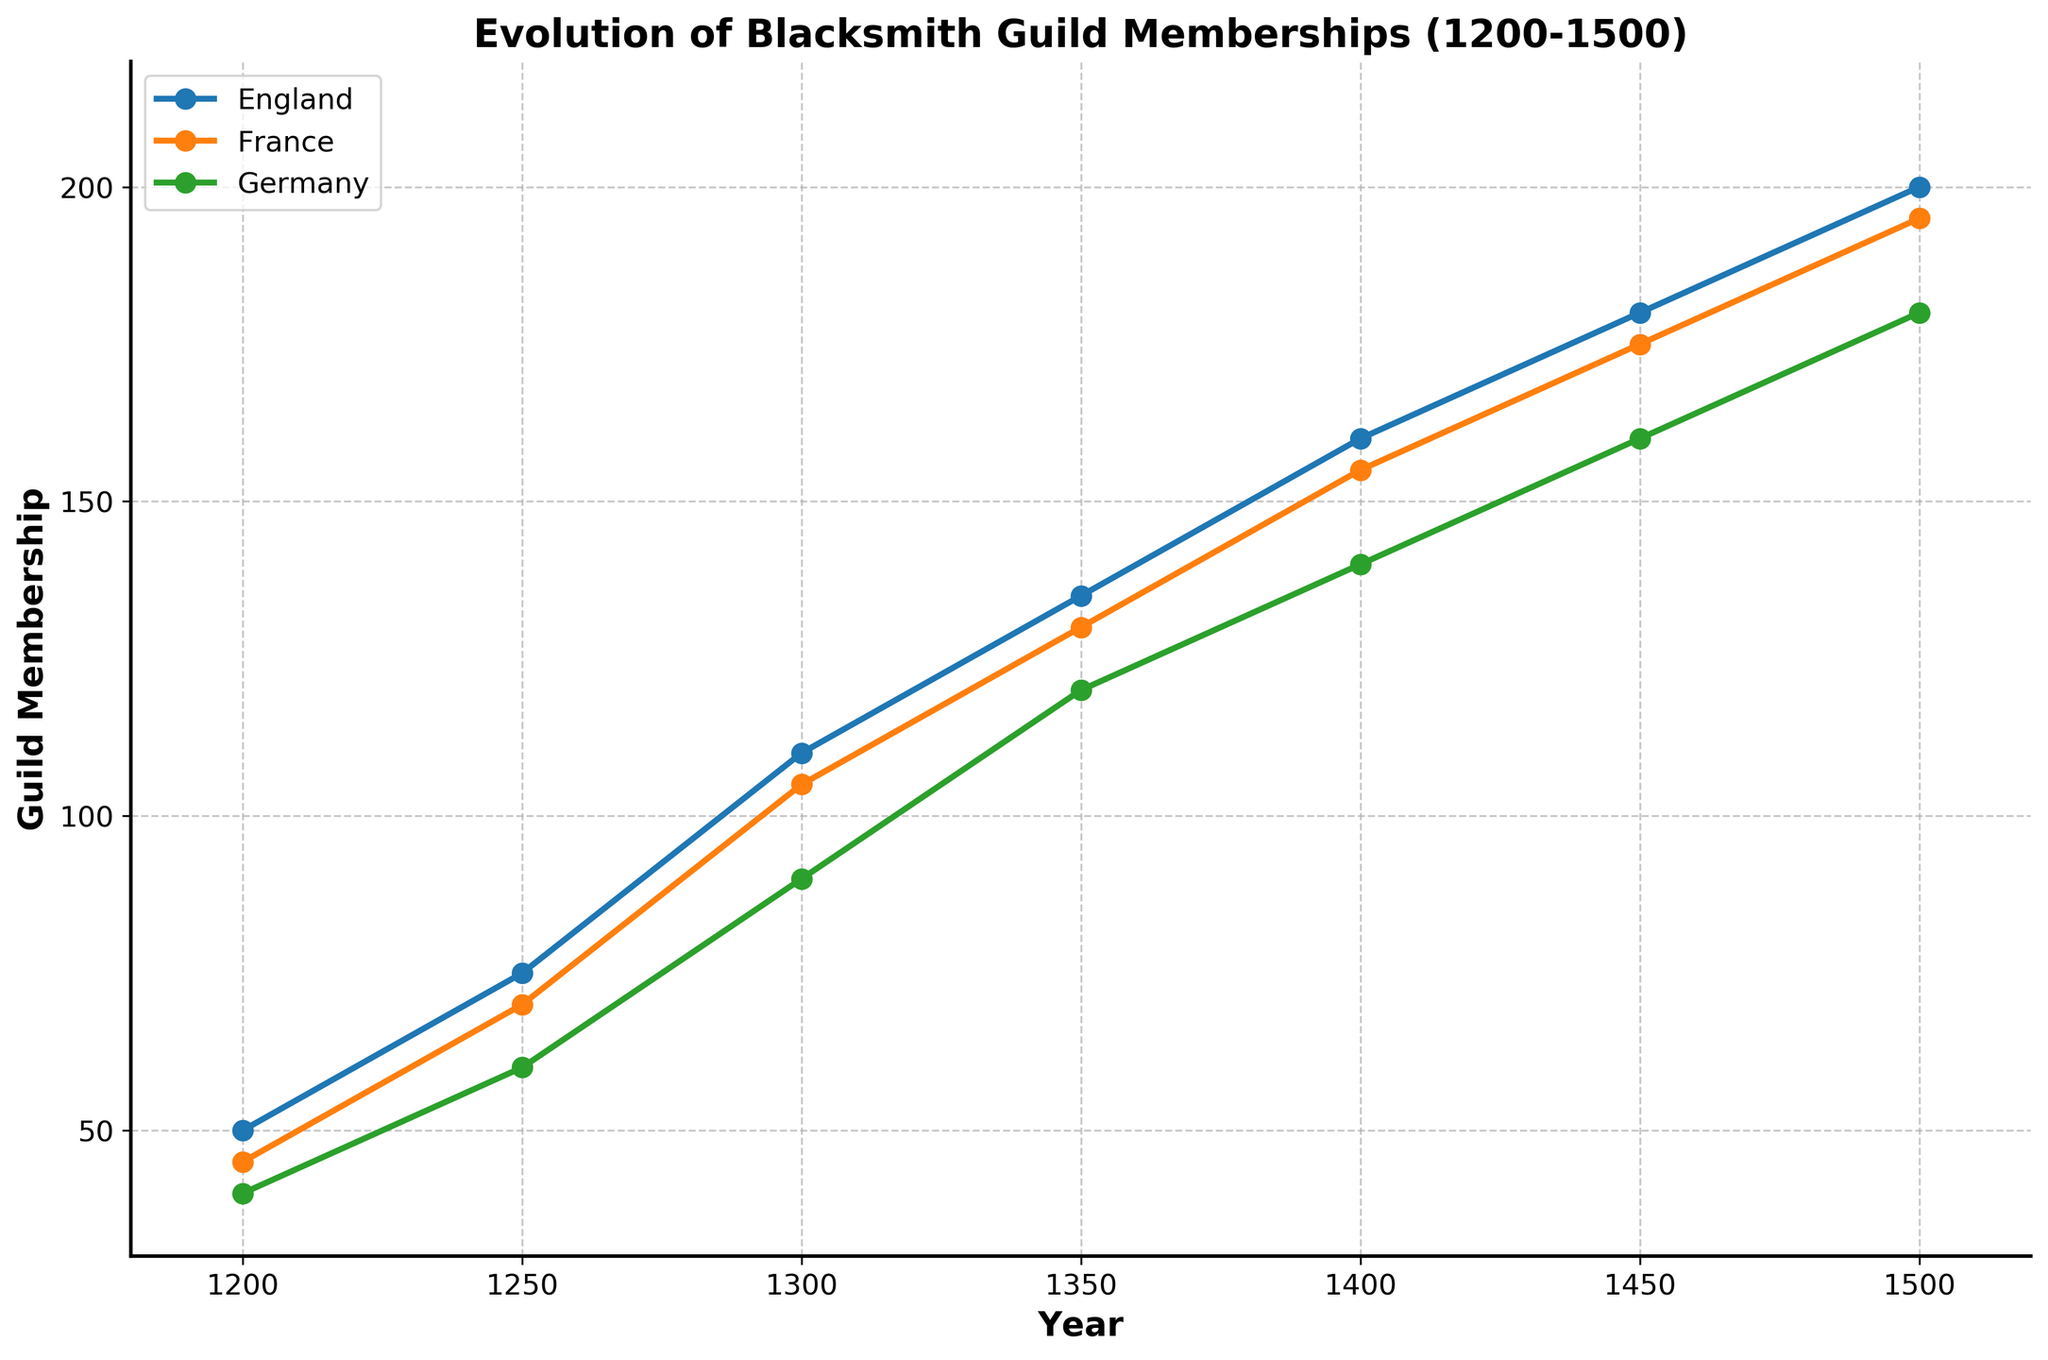what is the title of the plot? The title of the plot is prominently displayed at the top. It summarizes the data presented.
Answer: Evolution of Blacksmith Guild Memberships (1200-1500) How many regions are represented in the plot? By looking at the legend, we can count the number of distinct entries. Each entry corresponds to a different region.
Answer: 3 what is the guild membership in England in 1400? Locate the year 1400 on the x-axis and find the corresponding point for England on the plot.
Answer: 160 What is the average guild membership in Germany between 1250 and 1300? The guild memberships for Germany in those years are 60 and 90. To find the average, add them together and divide by 2. (60 + 90)/2 = 75
Answer: 75 Which year shows the highest guild membership for France? Inspect the data points for France and determine which one has the highest y-value. This occurs in 1500 with a membership of 195.
Answer: 1500 Did England's guild membership grow more than France's between 1200 and 1500? Calculate the difference in guild membership for both England and France from 1200 to 1500. For England: 200 - 50 = 150. For France: 195 - 45 = 150. Since both have an increase of 150, they grew equally.
Answer: No How much higher was the guild membership in England compared to Germany in 1350? Subtract Germany's guild membership in 1350 from England's for the same year. 135 - 120 = 15
Answer: 15 What's the trend of guild membership in all regions over time? Observe the overall direction of data points across all regions from 1200 to 1500. All regions show a consistently increasing trend in guild memberships.
Answer: Increasing When did France first surpass 100 guild members? Locate the year where France's guild membership exceeds 100 for the first time. This occurs in 1300, where the membership is 105.
Answer: 1300 